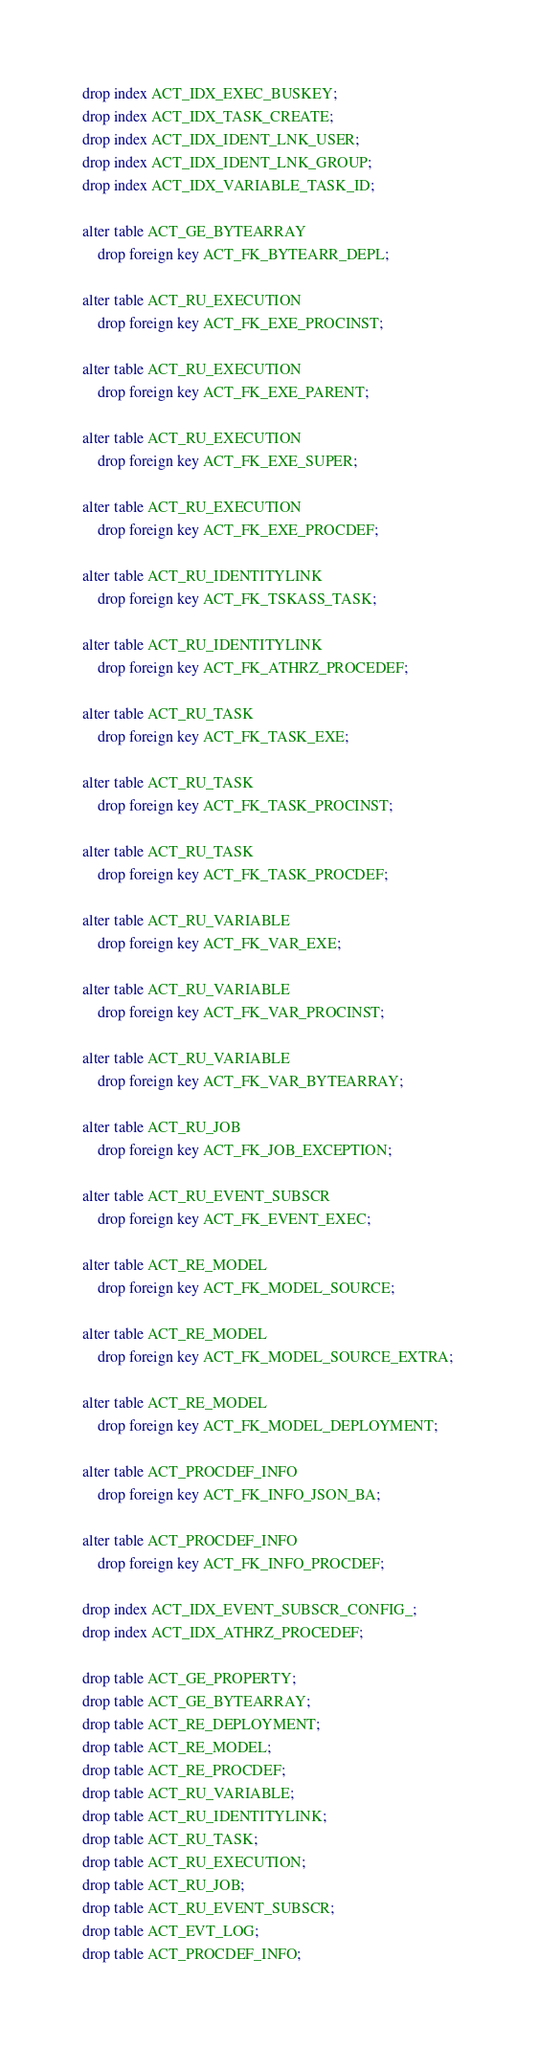Convert code to text. <code><loc_0><loc_0><loc_500><loc_500><_SQL_>drop index ACT_IDX_EXEC_BUSKEY;
drop index ACT_IDX_TASK_CREATE;
drop index ACT_IDX_IDENT_LNK_USER;
drop index ACT_IDX_IDENT_LNK_GROUP;
drop index ACT_IDX_VARIABLE_TASK_ID;

alter table ACT_GE_BYTEARRAY 
    drop foreign key ACT_FK_BYTEARR_DEPL;

alter table ACT_RU_EXECUTION
    drop foreign key ACT_FK_EXE_PROCINST;

alter table ACT_RU_EXECUTION 
    drop foreign key ACT_FK_EXE_PARENT;

alter table ACT_RU_EXECUTION 
    drop foreign key ACT_FK_EXE_SUPER;
    
alter table ACT_RU_EXECUTION 
    drop foreign key ACT_FK_EXE_PROCDEF;

alter table ACT_RU_IDENTITYLINK
    drop foreign key ACT_FK_TSKASS_TASK;

alter table ACT_RU_IDENTITYLINK
    drop foreign key ACT_FK_ATHRZ_PROCEDEF;

alter table ACT_RU_TASK
	drop foreign key ACT_FK_TASK_EXE;

alter table ACT_RU_TASK
	drop foreign key ACT_FK_TASK_PROCINST;
	
alter table ACT_RU_TASK
	drop foreign key ACT_FK_TASK_PROCDEF;
    
alter table ACT_RU_VARIABLE
    drop foreign key ACT_FK_VAR_EXE;
    
alter table ACT_RU_VARIABLE
	drop foreign key ACT_FK_VAR_PROCINST;    

alter table ACT_RU_VARIABLE
    drop foreign key ACT_FK_VAR_BYTEARRAY;

alter table ACT_RU_JOB
    drop foreign key ACT_FK_JOB_EXCEPTION;
    
alter table ACT_RU_EVENT_SUBSCR
    drop foreign key ACT_FK_EVENT_EXEC;

alter table ACT_RE_MODEL 
    drop foreign key ACT_FK_MODEL_SOURCE;

alter table ACT_RE_MODEL 
    drop foreign key ACT_FK_MODEL_SOURCE_EXTRA; 
    
alter table ACT_RE_MODEL 
    drop foreign key ACT_FK_MODEL_DEPLOYMENT; 

alter table ACT_PROCDEF_INFO 
    drop foreign key ACT_FK_INFO_JSON_BA;

alter table ACT_PROCDEF_INFO 
    drop foreign key ACT_FK_INFO_PROCDEF;

drop index ACT_IDX_EVENT_SUBSCR_CONFIG_;
drop index ACT_IDX_ATHRZ_PROCEDEF;
    
drop table ACT_GE_PROPERTY;
drop table ACT_GE_BYTEARRAY;
drop table ACT_RE_DEPLOYMENT;
drop table ACT_RE_MODEL;
drop table ACT_RE_PROCDEF;
drop table ACT_RU_VARIABLE;
drop table ACT_RU_IDENTITYLINK;
drop table ACT_RU_TASK;
drop table ACT_RU_EXECUTION;
drop table ACT_RU_JOB;
drop table ACT_RU_EVENT_SUBSCR;
drop table ACT_EVT_LOG;
drop table ACT_PROCDEF_INFO;
</code> 